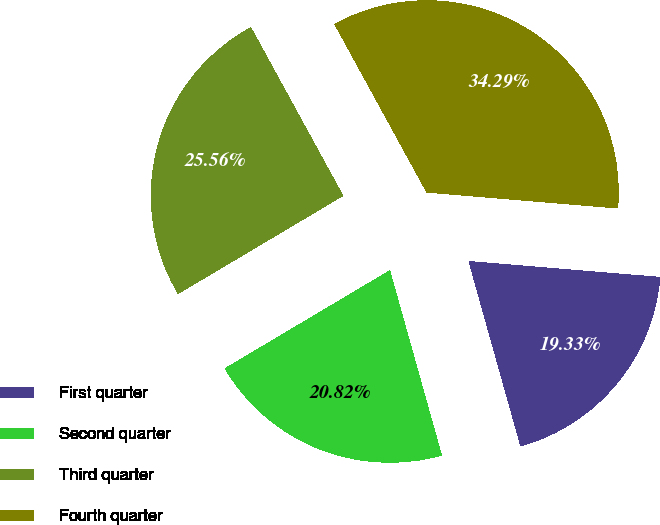Convert chart to OTSL. <chart><loc_0><loc_0><loc_500><loc_500><pie_chart><fcel>First quarter<fcel>Second quarter<fcel>Third quarter<fcel>Fourth quarter<nl><fcel>19.33%<fcel>20.82%<fcel>25.56%<fcel>34.29%<nl></chart> 